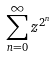<formula> <loc_0><loc_0><loc_500><loc_500>\sum _ { n = 0 } ^ { \infty } z ^ { 2 ^ { n } }</formula> 